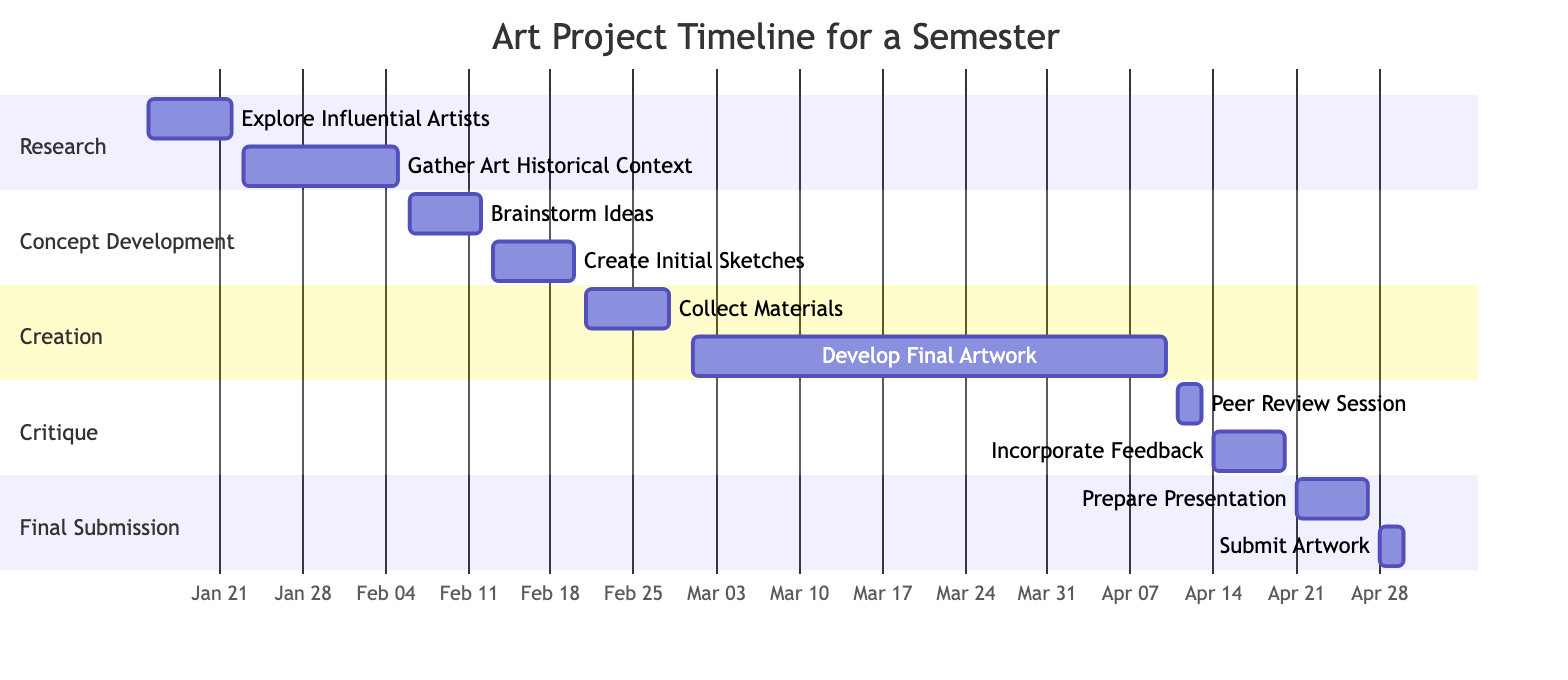What is the duration of the "Research" phase? The "Research" phase includes two tasks: "Explore Influential Artists" from January 15 to January 22 and "Gather Art Historical Context" from January 23 to February 5. The total duration is from January 15 to February 5, which is 22 days.
Answer: 22 days Which task comes right after "Create Initial Sketches"? "Create Initial Sketches" ends on February 20, and the next task listed is "Collect Materials," which starts on February 21. Therefore, "Collect Materials" comes right after "Create Initial Sketches."
Answer: Collect Materials How many tasks are in the "Creation" phase? The "Creation" phase consists of two tasks: "Collect Materials" and "Develop Final Artwork." Therefore, there are 2 tasks in this phase.
Answer: 2 tasks What is the end date for the "Final Submission" phase? The "Final Submission" phase includes two tasks, with the last task "Submit Artwork" ending on April 30. Therefore, April 30 is the end date for the phase.
Answer: April 30 When does the "Incorporate Feedback" task take place? "Incorporate Feedback" starts on April 14 and ends on April 20. Therefore, the task takes place during this date range.
Answer: April 14 to April 20 How many total phases are represented in this Gantt chart? The diagram outlines five distinct phases: Research, Concept Development, Creation, Critique, and Final Submission. Thus, there are 5 phases in total.
Answer: 5 phases Which phase has the earliest start date? The "Research" phase begins with the task "Explore Influential Artists" starting on January 15, which is before any other phase starts. Thus, "Research" has the earliest start date.
Answer: Research What task starts immediately after the “Develop Final Artwork”? The task that starts immediately after "Develop Final Artwork," which ends on April 10, is "Peer Review Session," commencing on April 11.
Answer: Peer Review Session What is the total number of tasks in the project timeline? By counting all tasks across the five phases, the total comes to ten tasks: 2 in Research, 2 in Concept Development, 2 in Creation, 2 in Critique, and 2 in Final Submission. Thus, there are 10 tasks in total.
Answer: 10 tasks 